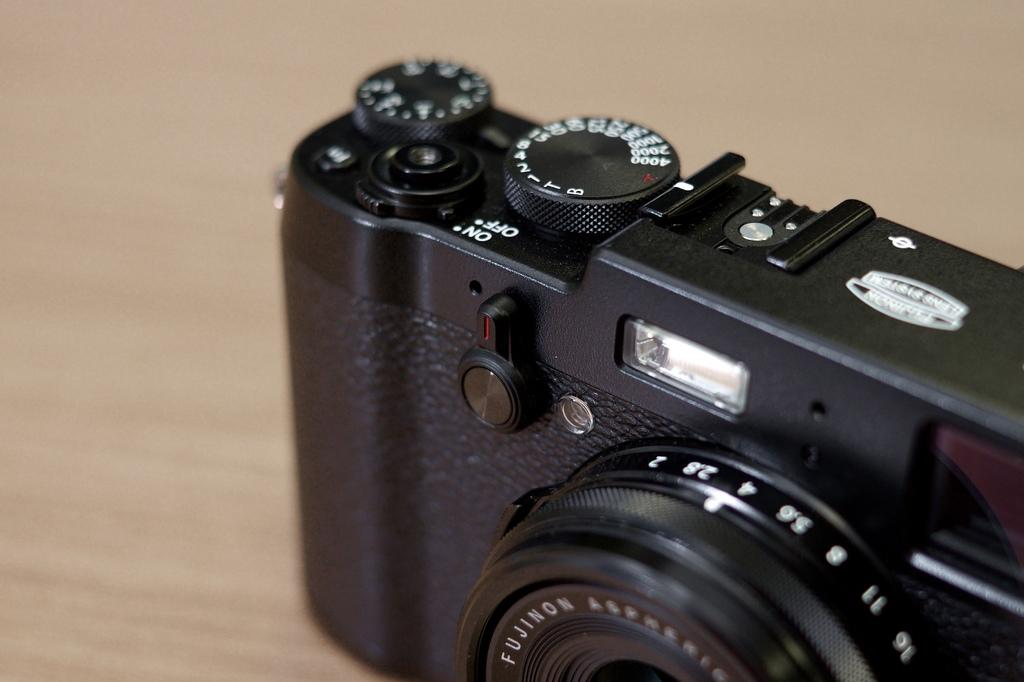<image>
Write a terse but informative summary of the picture. A camera's controls include a dial marked both ON and OFF. 